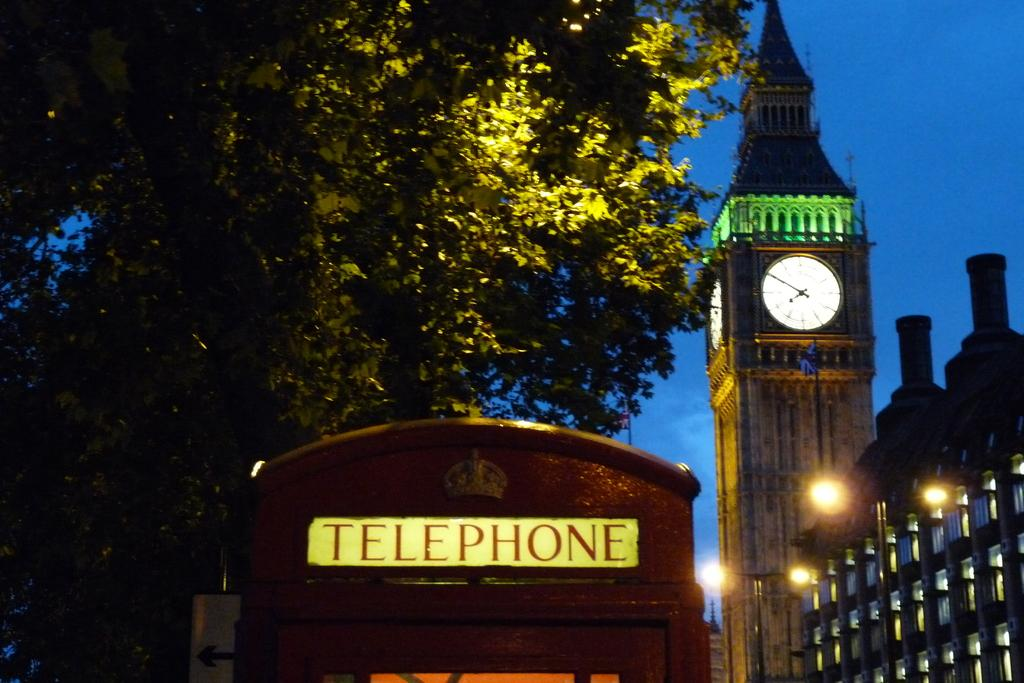<image>
Give a short and clear explanation of the subsequent image. A telephone booth says "TELEPHONE" at the top. 